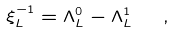Convert formula to latex. <formula><loc_0><loc_0><loc_500><loc_500>\xi _ { L } ^ { - 1 } = \Lambda _ { L } ^ { 0 } - \Lambda _ { L } ^ { 1 } \ \ ,</formula> 